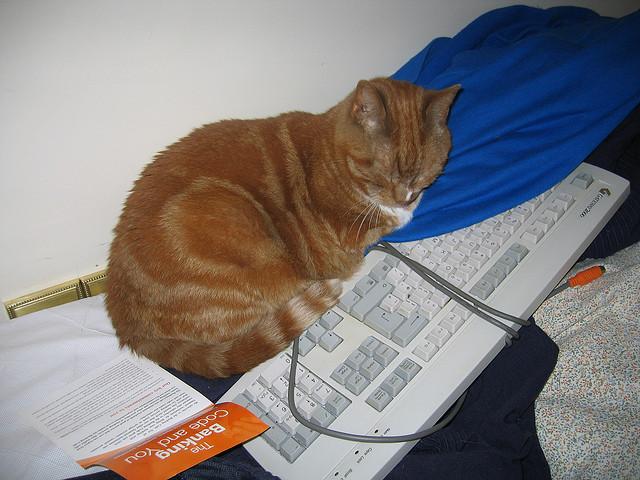How many keyboards in the picture?
Short answer required. 1. Is the cat sleeping?
Give a very brief answer. Yes. What is written on the orange piece of paper?
Concise answer only. Banking code and you. What is the cat laying next to?
Be succinct. Keyboard. What type of technology is depicted?
Keep it brief. Keyboard. What is in front of the cat?
Keep it brief. Keyboard. 